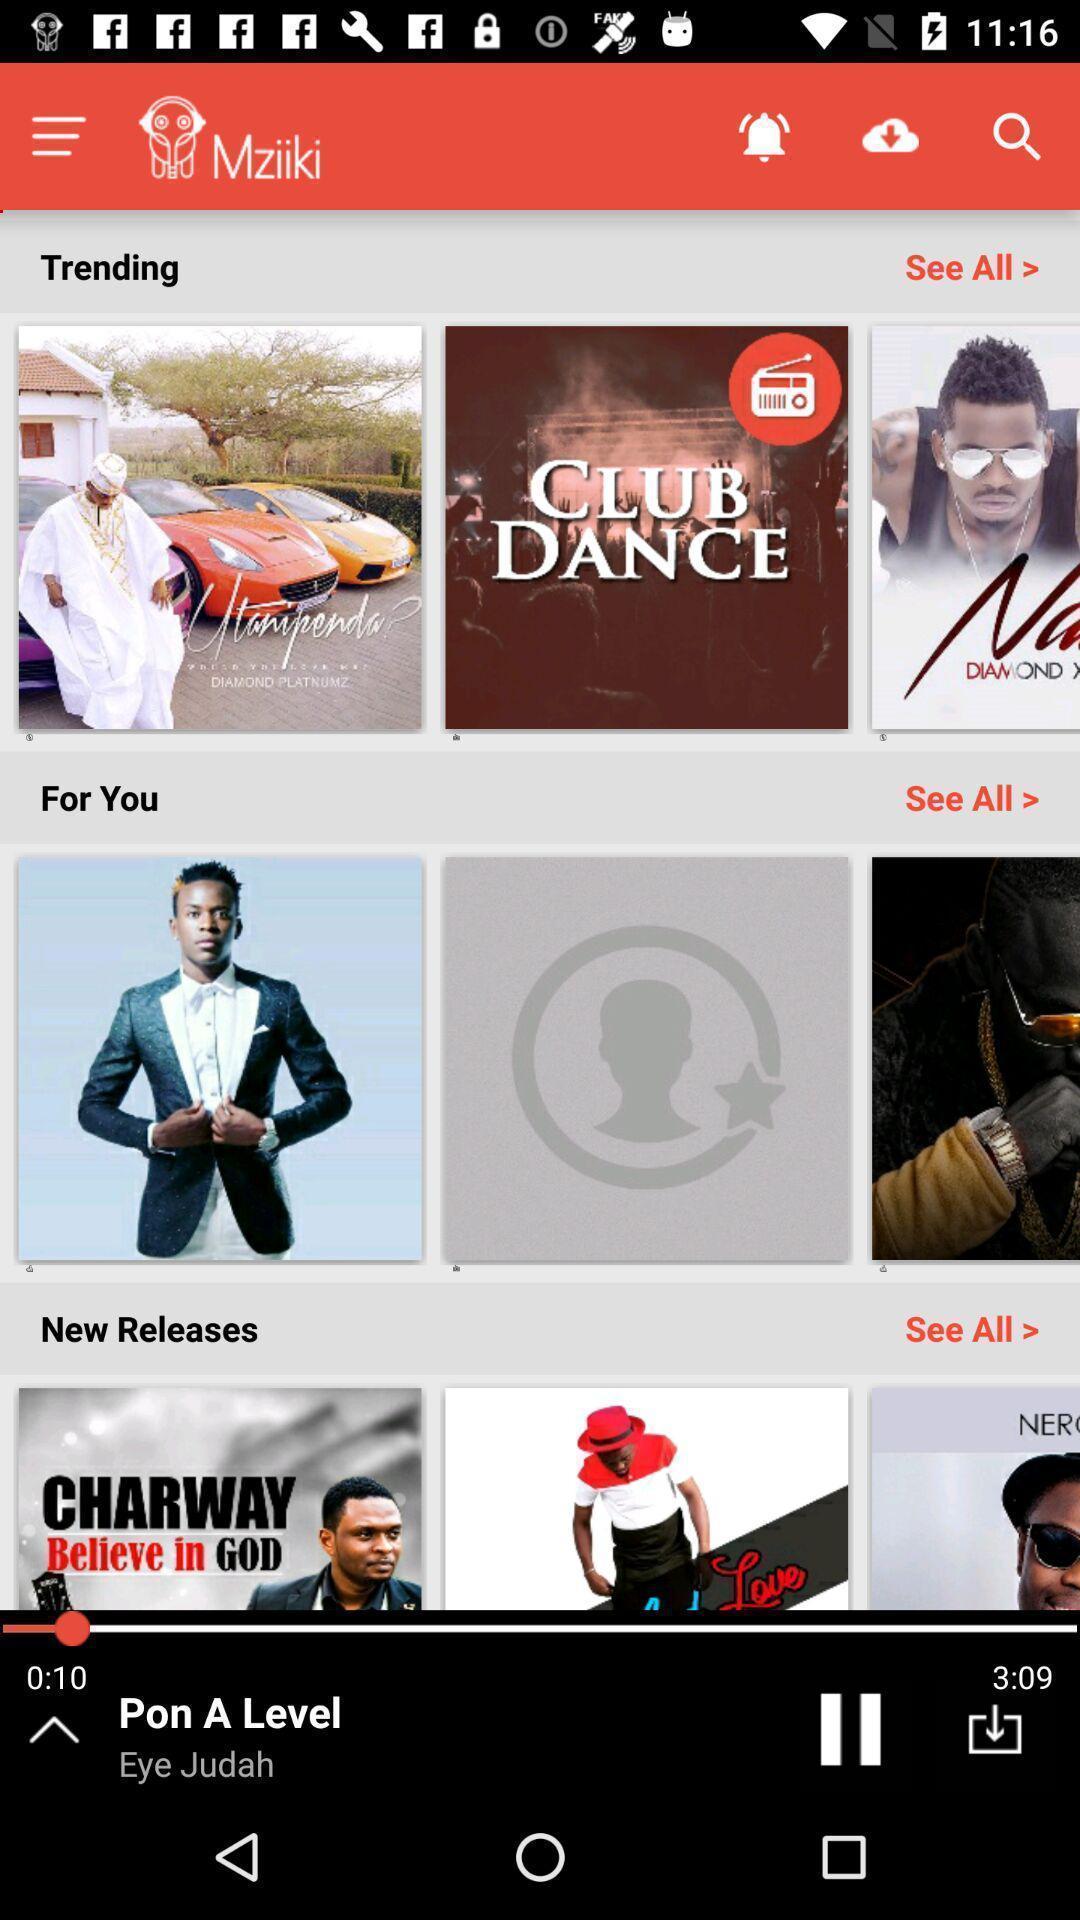Provide a textual representation of this image. Trending video of the app. 